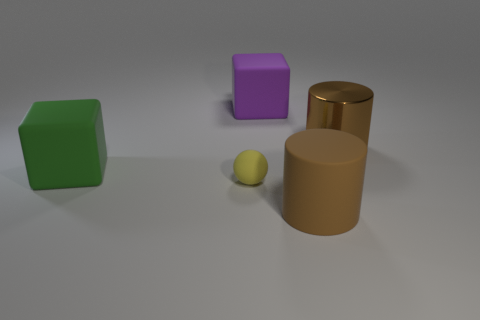What number of things are either small brown blocks or yellow balls in front of the big shiny cylinder?
Provide a short and direct response. 1. What is the large brown cylinder behind the brown matte cylinder right of the big rubber cube that is behind the shiny thing made of?
Provide a short and direct response. Metal. Is there any other thing that has the same material as the purple cube?
Make the answer very short. Yes. Do the metallic thing that is behind the large green thing and the tiny rubber ball have the same color?
Offer a very short reply. No. What number of purple things are either matte cubes or cylinders?
Your answer should be compact. 1. How many other things are there of the same shape as the big purple thing?
Your response must be concise. 1. Are the yellow sphere and the green cube made of the same material?
Ensure brevity in your answer.  Yes. What is the thing that is both on the left side of the large purple matte cube and behind the matte ball made of?
Offer a terse response. Rubber. There is a big block that is behind the big green rubber thing; what is its color?
Provide a short and direct response. Purple. Are there more tiny yellow spheres behind the brown shiny cylinder than tiny objects?
Provide a succinct answer. No. 